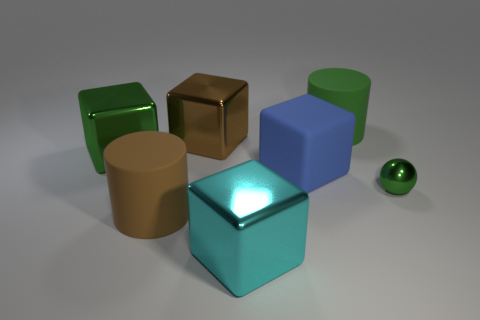What number of other things are the same size as the brown metallic thing?
Make the answer very short. 5. There is a block that is in front of the tiny thing; is its size the same as the brown thing behind the blue rubber cube?
Provide a succinct answer. Yes. How many things are either big green things or shiny things in front of the blue rubber object?
Offer a very short reply. 4. There is a cylinder in front of the green shiny block; what size is it?
Give a very brief answer. Large. Are there fewer big brown objects behind the green metallic sphere than tiny green objects behind the large green rubber cylinder?
Offer a very short reply. No. What material is the large thing that is behind the big green cube and left of the big cyan object?
Make the answer very short. Metal. What is the shape of the large metal thing that is to the left of the matte cylinder that is in front of the tiny sphere?
Offer a very short reply. Cube. Does the large rubber block have the same color as the tiny ball?
Provide a succinct answer. No. How many brown objects are cubes or rubber blocks?
Provide a short and direct response. 1. Are there any big blue rubber blocks right of the large rubber cube?
Provide a succinct answer. No. 